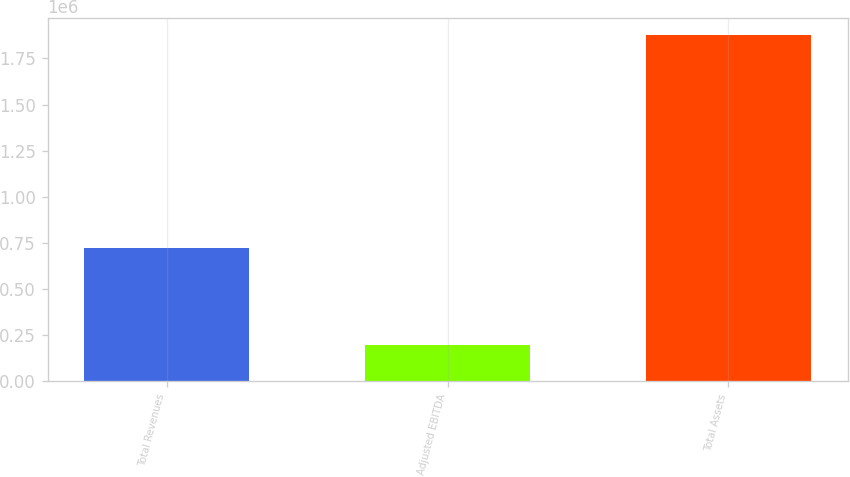<chart> <loc_0><loc_0><loc_500><loc_500><bar_chart><fcel>Total Revenues<fcel>Adjusted EBITDA<fcel>Total Assets<nl><fcel>719571<fcel>196683<fcel>1.87568e+06<nl></chart> 